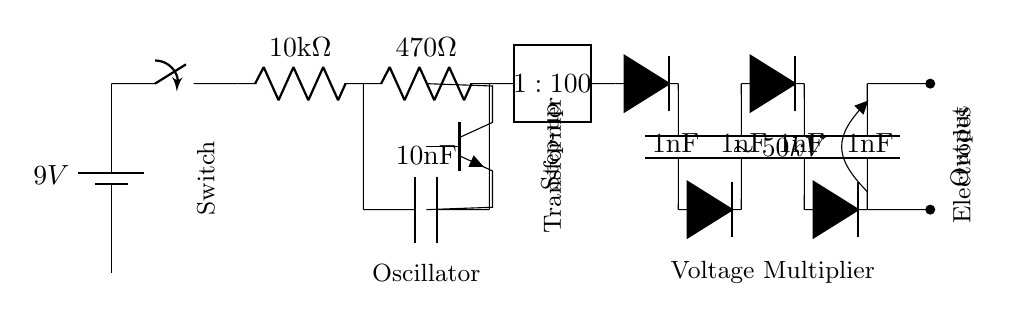What is the voltage of the power source? The power source in the circuit is labeled as a nine-volt battery, indicating that it provides a voltage of 9V.
Answer: 9V What type of switch is used in this circuit? The diagram shows a single-pole single-throw switch (SPST), characterized by its two terminal connections that open or close the circuit.
Answer: SPST What is the resistance value of the first resistor? The first resistor in the circuit is labeled as 10 kilohms, which indicates its resistance value.
Answer: 10kΩ What does the transformer do in this circuit? The transformer is labeled with a turns ratio of 1:100, which means it steps up the voltage from the input to a significantly higher voltage output, suitable for the function of a stun gun.
Answer: Step-up How many capacitors are in the voltage multiplier section? The voltage multiplier section contains five capacitors, as seen by counting the labeled components that are in the configuration following the transformer, which are in series and parallel arrangements.
Answer: 5 What is the approximate output voltage generated by the circuit? The output section indicates a voltage of approximately 50,000 volts, which is derived from the voltage multiplication of the low input current through the capacitors and diodes in the multiplier circuit.
Answer: 50kV What is the purpose of the oscillator in this circuit? The oscillator in this circuit converts the direct current from the battery into a pulsating current, necessary for the transformer to operate effectively and raise the voltage.
Answer: Generate pulses 